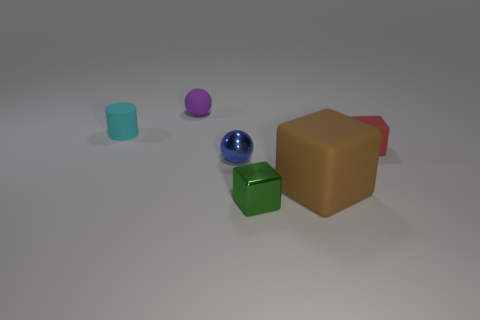Is the size of the matte block that is behind the large rubber block the same as the cube that is in front of the big rubber object? No, the sizes of the two objects appear to be different. The matte block behind the large brown rubber block looks smaller than the cube in front of it. 